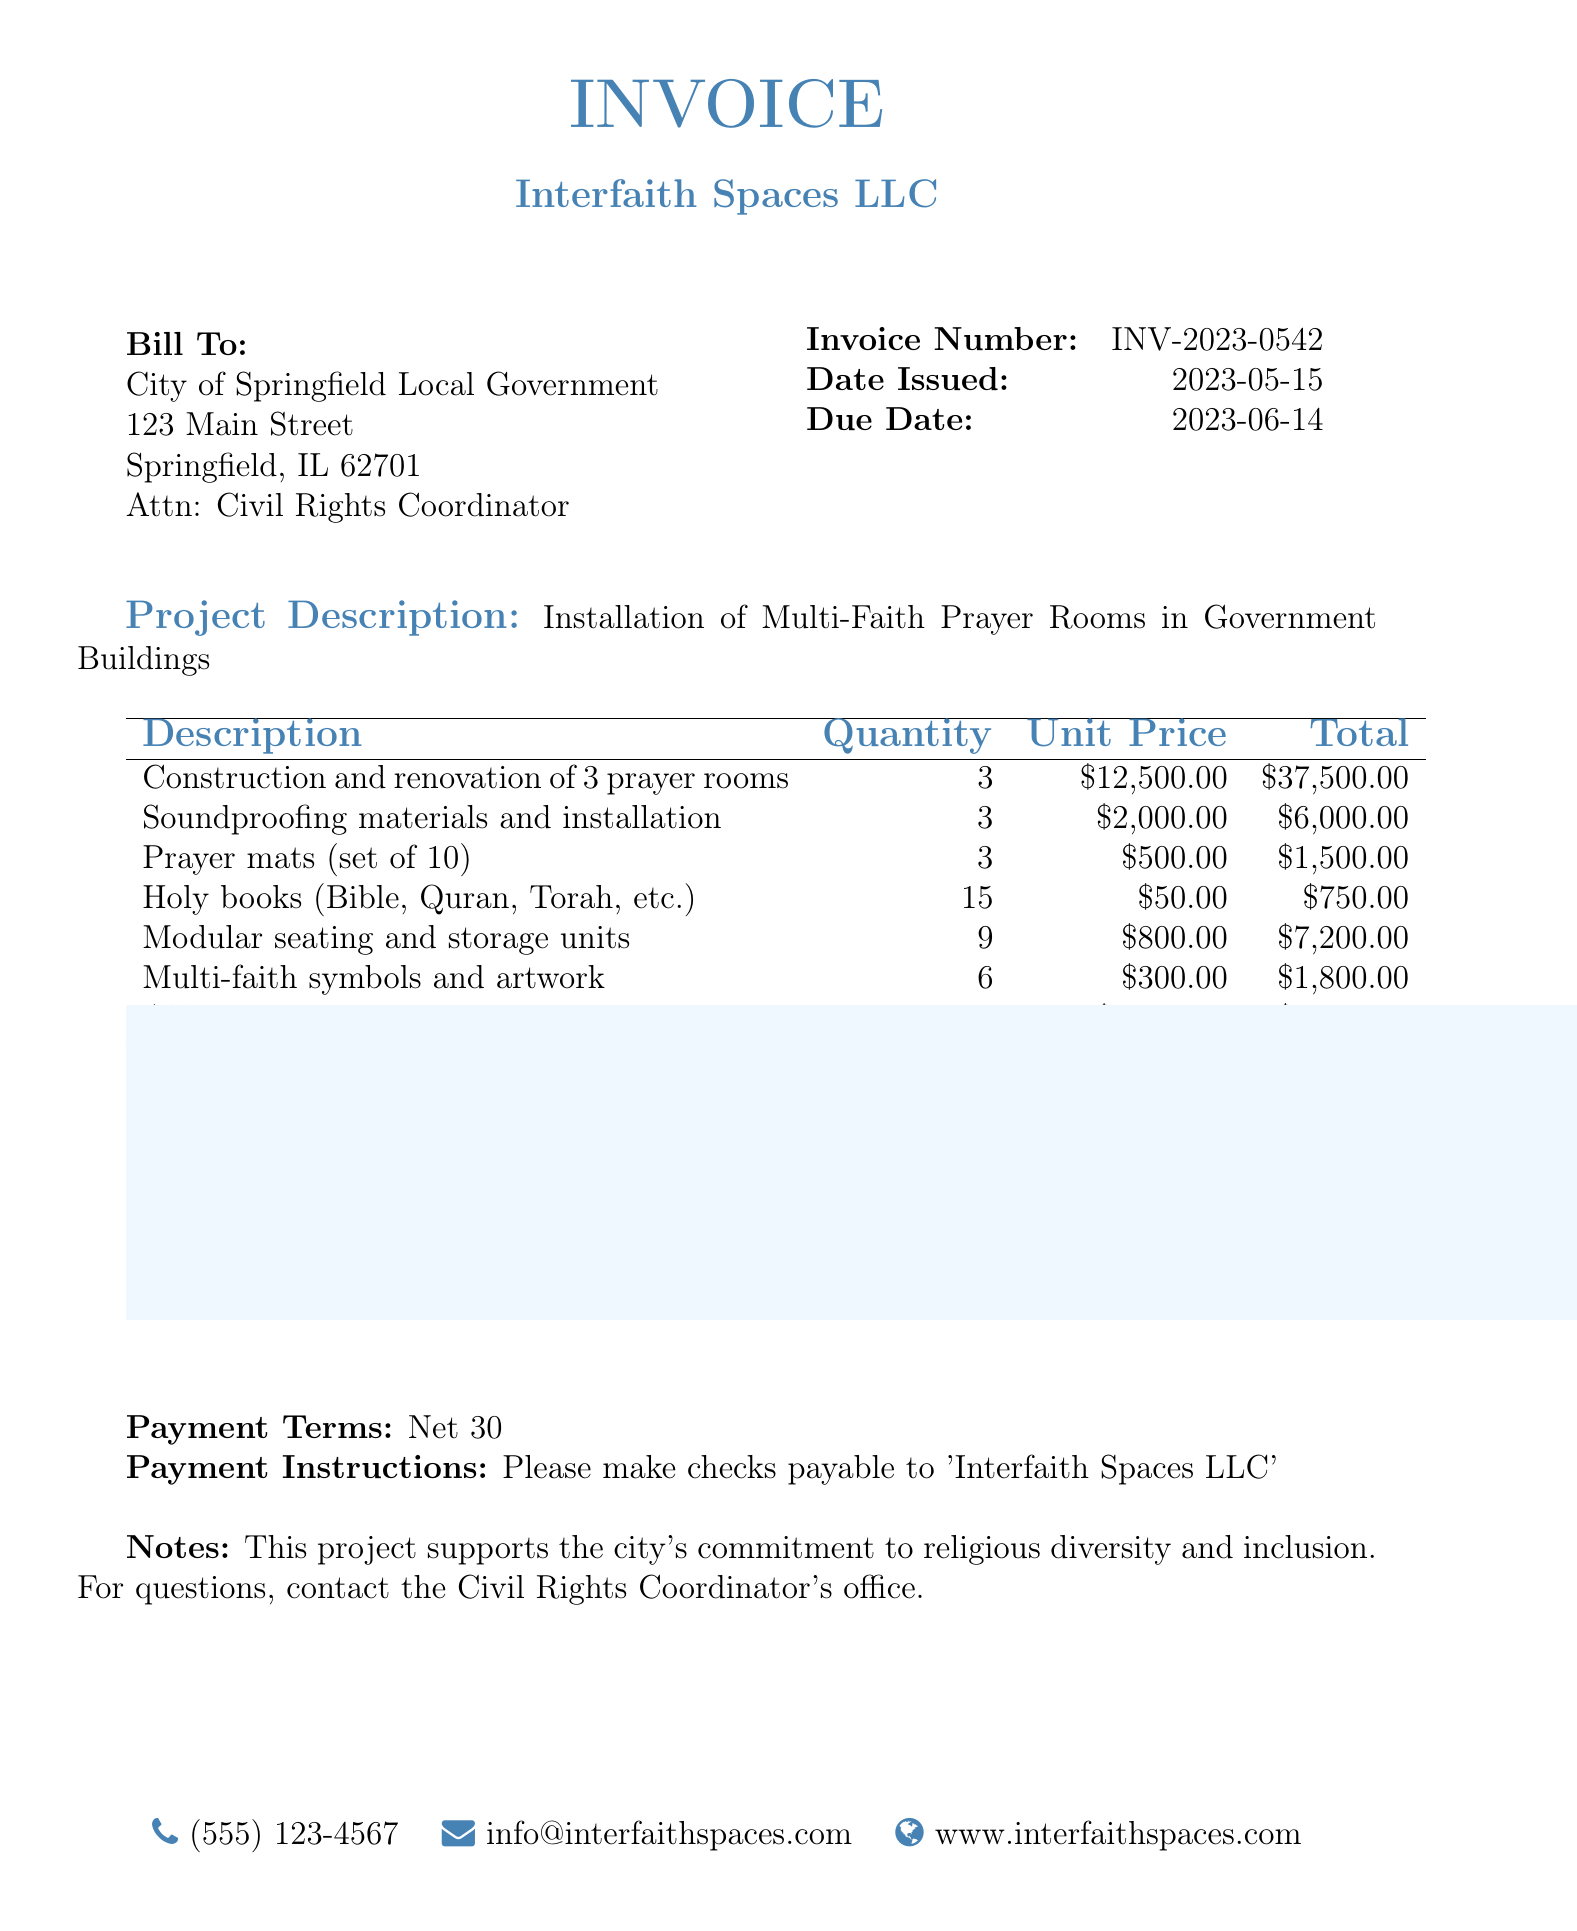What is the invoice number? The invoice number is a unique identifier for the bill, which is shown in the document.
Answer: INV-2023-0542 What is the date issued? The date issued indicates when the invoice was created. This date is listed in the document.
Answer: 2023-05-15 What is the total due amount? The total due amount is the final cost that must be paid and is provided at the bottom of the invoice.
Answer: $63,990.00 How many prayer rooms are being constructed? The number of prayer rooms being constructed is specified in the project description and inventory.
Answer: 3 What is the cost of soundproofing materials and installation per room? The cost per room for soundproofing is detailed in the pricing table.
Answer: $2,000.00 What project supports the city's commitment? The document mentions that this project supports a specific initiative related to the city, which indicates its importance.
Answer: Religious diversity and inclusion What is the payment term specified in the invoice? The payment term provides information on when the payment is expected to be completed.
Answer: Net 30 How many holy books are included in the invoice? The quantity of holy books is stated in the product description of the invoice.
Answer: 15 Who should checks be made payable to? The payment instructions specify to whom the payment should be directed.
Answer: Interfaith Spaces LLC 